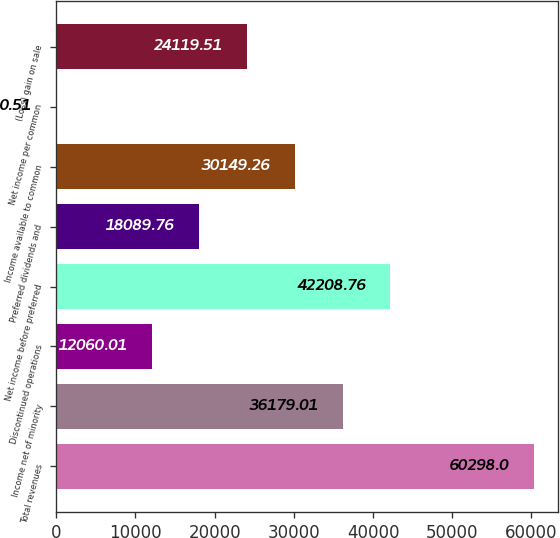Convert chart. <chart><loc_0><loc_0><loc_500><loc_500><bar_chart><fcel>Total revenues<fcel>Income net of minority<fcel>Discontinued operations<fcel>Net income before preferred<fcel>Preferred dividends and<fcel>Income available to common<fcel>Net income per common<fcel>(Loss) gain on sale<nl><fcel>60298<fcel>36179<fcel>12060<fcel>42208.8<fcel>18089.8<fcel>30149.3<fcel>0.51<fcel>24119.5<nl></chart> 